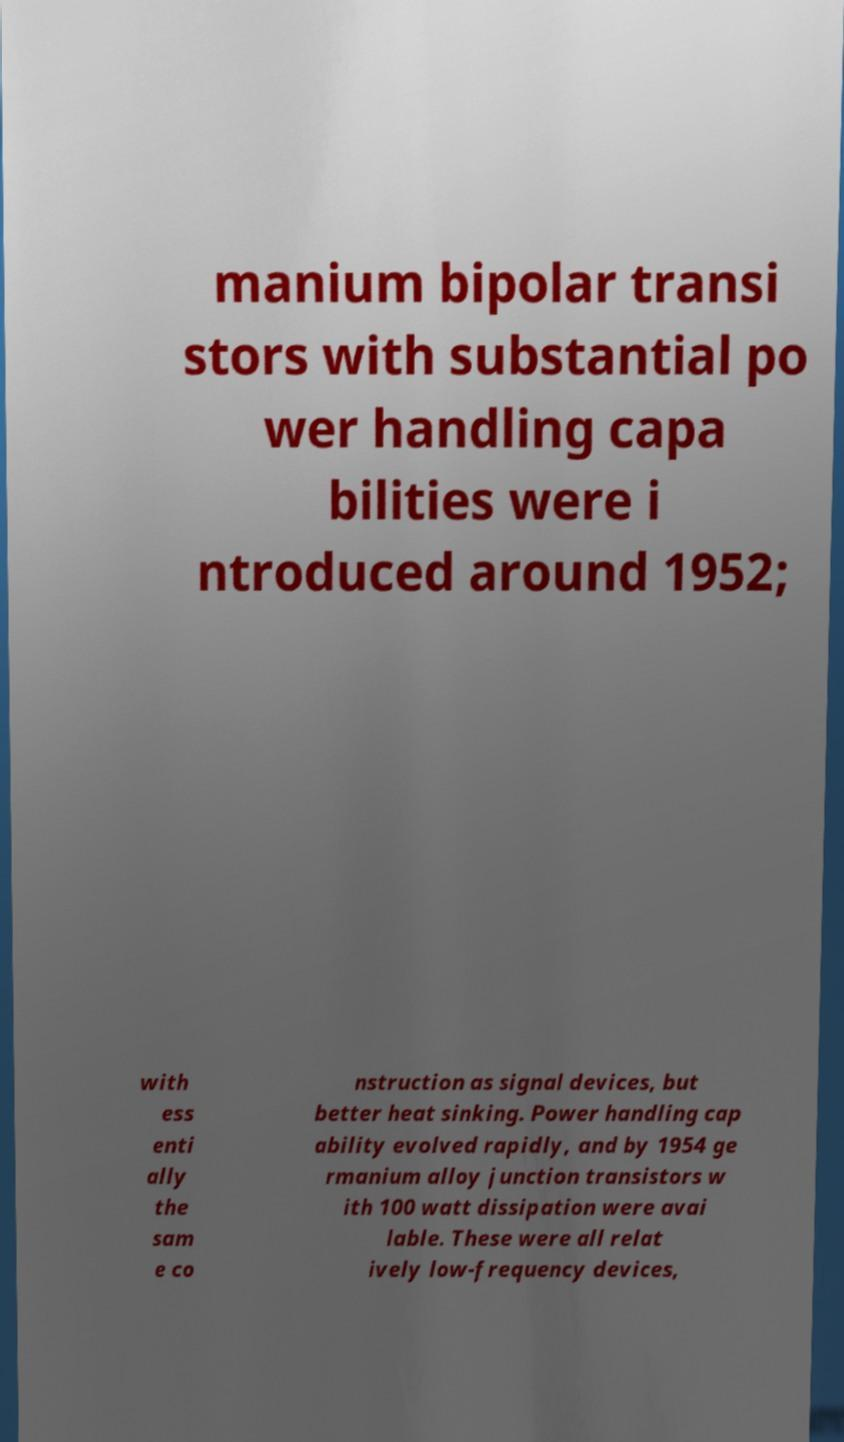What messages or text are displayed in this image? I need them in a readable, typed format. manium bipolar transi stors with substantial po wer handling capa bilities were i ntroduced around 1952; with ess enti ally the sam e co nstruction as signal devices, but better heat sinking. Power handling cap ability evolved rapidly, and by 1954 ge rmanium alloy junction transistors w ith 100 watt dissipation were avai lable. These were all relat ively low-frequency devices, 